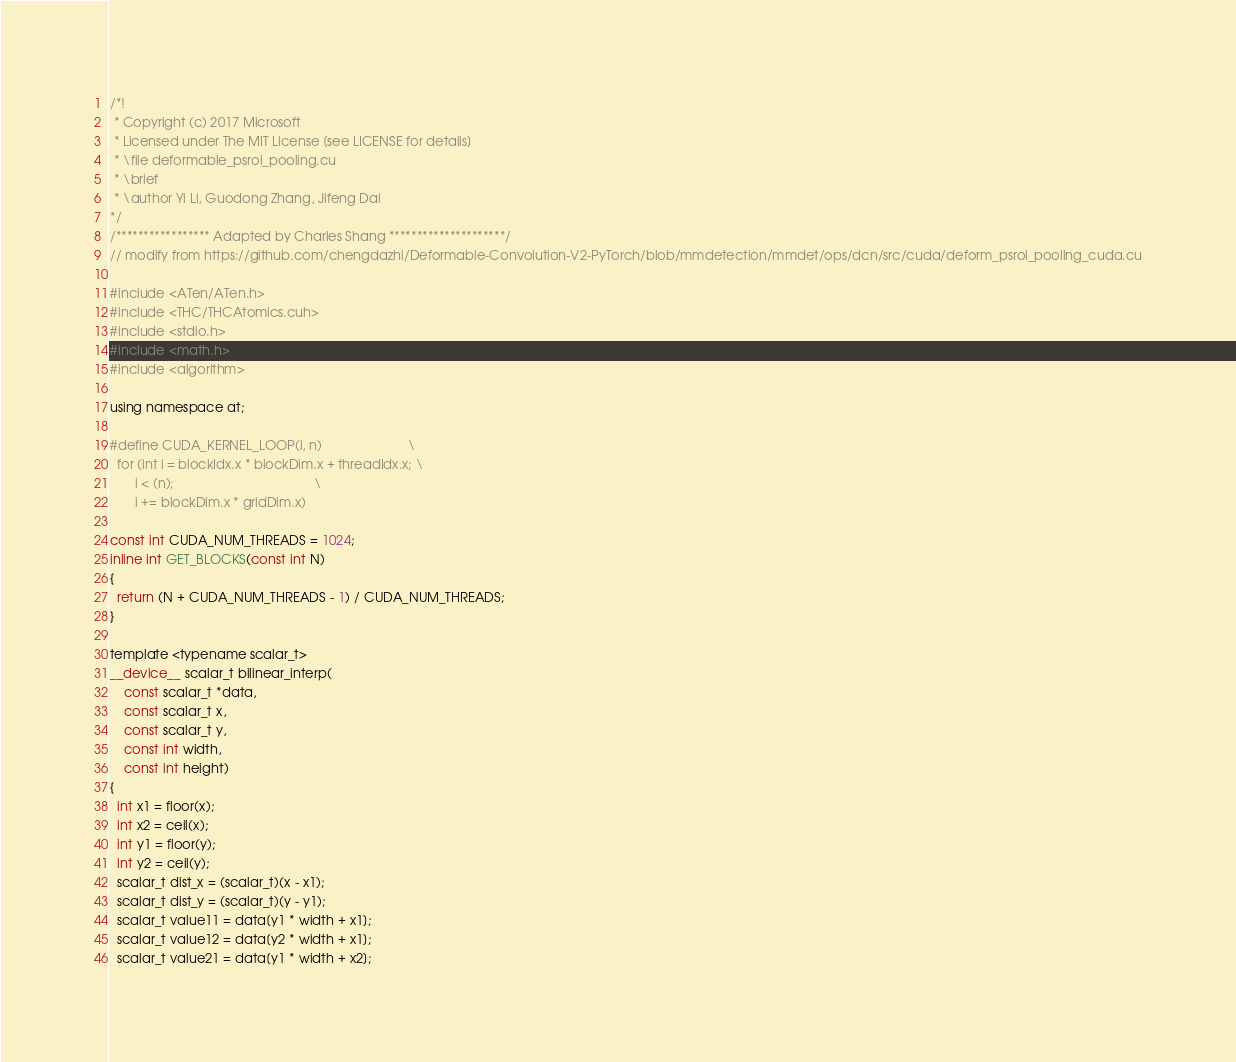Convert code to text. <code><loc_0><loc_0><loc_500><loc_500><_Cuda_>/*!
 * Copyright (c) 2017 Microsoft
 * Licensed under The MIT License [see LICENSE for details]
 * \file deformable_psroi_pooling.cu
 * \brief
 * \author Yi Li, Guodong Zhang, Jifeng Dai
*/
/***************** Adapted by Charles Shang *********************/
// modify from https://github.com/chengdazhi/Deformable-Convolution-V2-PyTorch/blob/mmdetection/mmdet/ops/dcn/src/cuda/deform_psroi_pooling_cuda.cu

#include <ATen/ATen.h>
#include <THC/THCAtomics.cuh>
#include <stdio.h>
#include <math.h>
#include <algorithm>

using namespace at;

#define CUDA_KERNEL_LOOP(i, n)                        \
  for (int i = blockIdx.x * blockDim.x + threadIdx.x; \
       i < (n);                                       \
       i += blockDim.x * gridDim.x)

const int CUDA_NUM_THREADS = 1024;
inline int GET_BLOCKS(const int N)
{
  return (N + CUDA_NUM_THREADS - 1) / CUDA_NUM_THREADS;
}

template <typename scalar_t>
__device__ scalar_t bilinear_interp(
    const scalar_t *data,
    const scalar_t x,
    const scalar_t y,
    const int width,
    const int height)
{
  int x1 = floor(x);
  int x2 = ceil(x);
  int y1 = floor(y);
  int y2 = ceil(y);
  scalar_t dist_x = (scalar_t)(x - x1);
  scalar_t dist_y = (scalar_t)(y - y1);
  scalar_t value11 = data[y1 * width + x1];
  scalar_t value12 = data[y2 * width + x1];
  scalar_t value21 = data[y1 * width + x2];</code> 